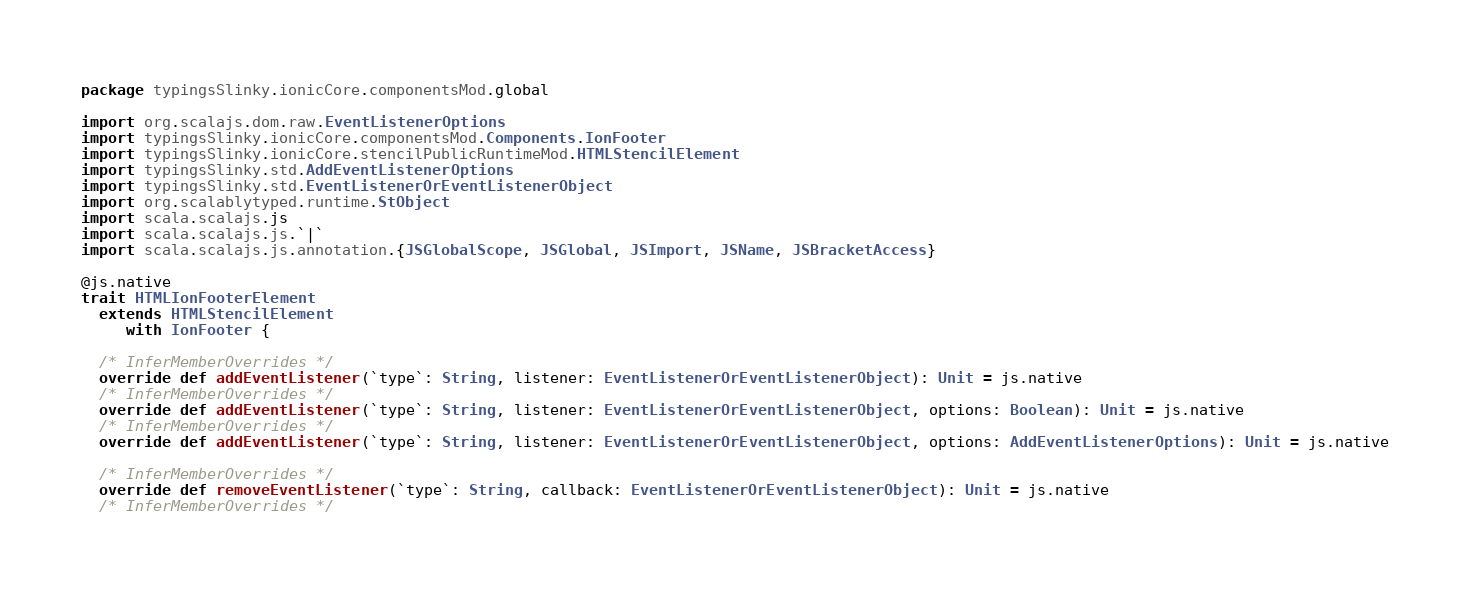Convert code to text. <code><loc_0><loc_0><loc_500><loc_500><_Scala_>package typingsSlinky.ionicCore.componentsMod.global

import org.scalajs.dom.raw.EventListenerOptions
import typingsSlinky.ionicCore.componentsMod.Components.IonFooter
import typingsSlinky.ionicCore.stencilPublicRuntimeMod.HTMLStencilElement
import typingsSlinky.std.AddEventListenerOptions
import typingsSlinky.std.EventListenerOrEventListenerObject
import org.scalablytyped.runtime.StObject
import scala.scalajs.js
import scala.scalajs.js.`|`
import scala.scalajs.js.annotation.{JSGlobalScope, JSGlobal, JSImport, JSName, JSBracketAccess}

@js.native
trait HTMLIonFooterElement
  extends HTMLStencilElement
     with IonFooter {
  
  /* InferMemberOverrides */
  override def addEventListener(`type`: String, listener: EventListenerOrEventListenerObject): Unit = js.native
  /* InferMemberOverrides */
  override def addEventListener(`type`: String, listener: EventListenerOrEventListenerObject, options: Boolean): Unit = js.native
  /* InferMemberOverrides */
  override def addEventListener(`type`: String, listener: EventListenerOrEventListenerObject, options: AddEventListenerOptions): Unit = js.native
  
  /* InferMemberOverrides */
  override def removeEventListener(`type`: String, callback: EventListenerOrEventListenerObject): Unit = js.native
  /* InferMemberOverrides */</code> 